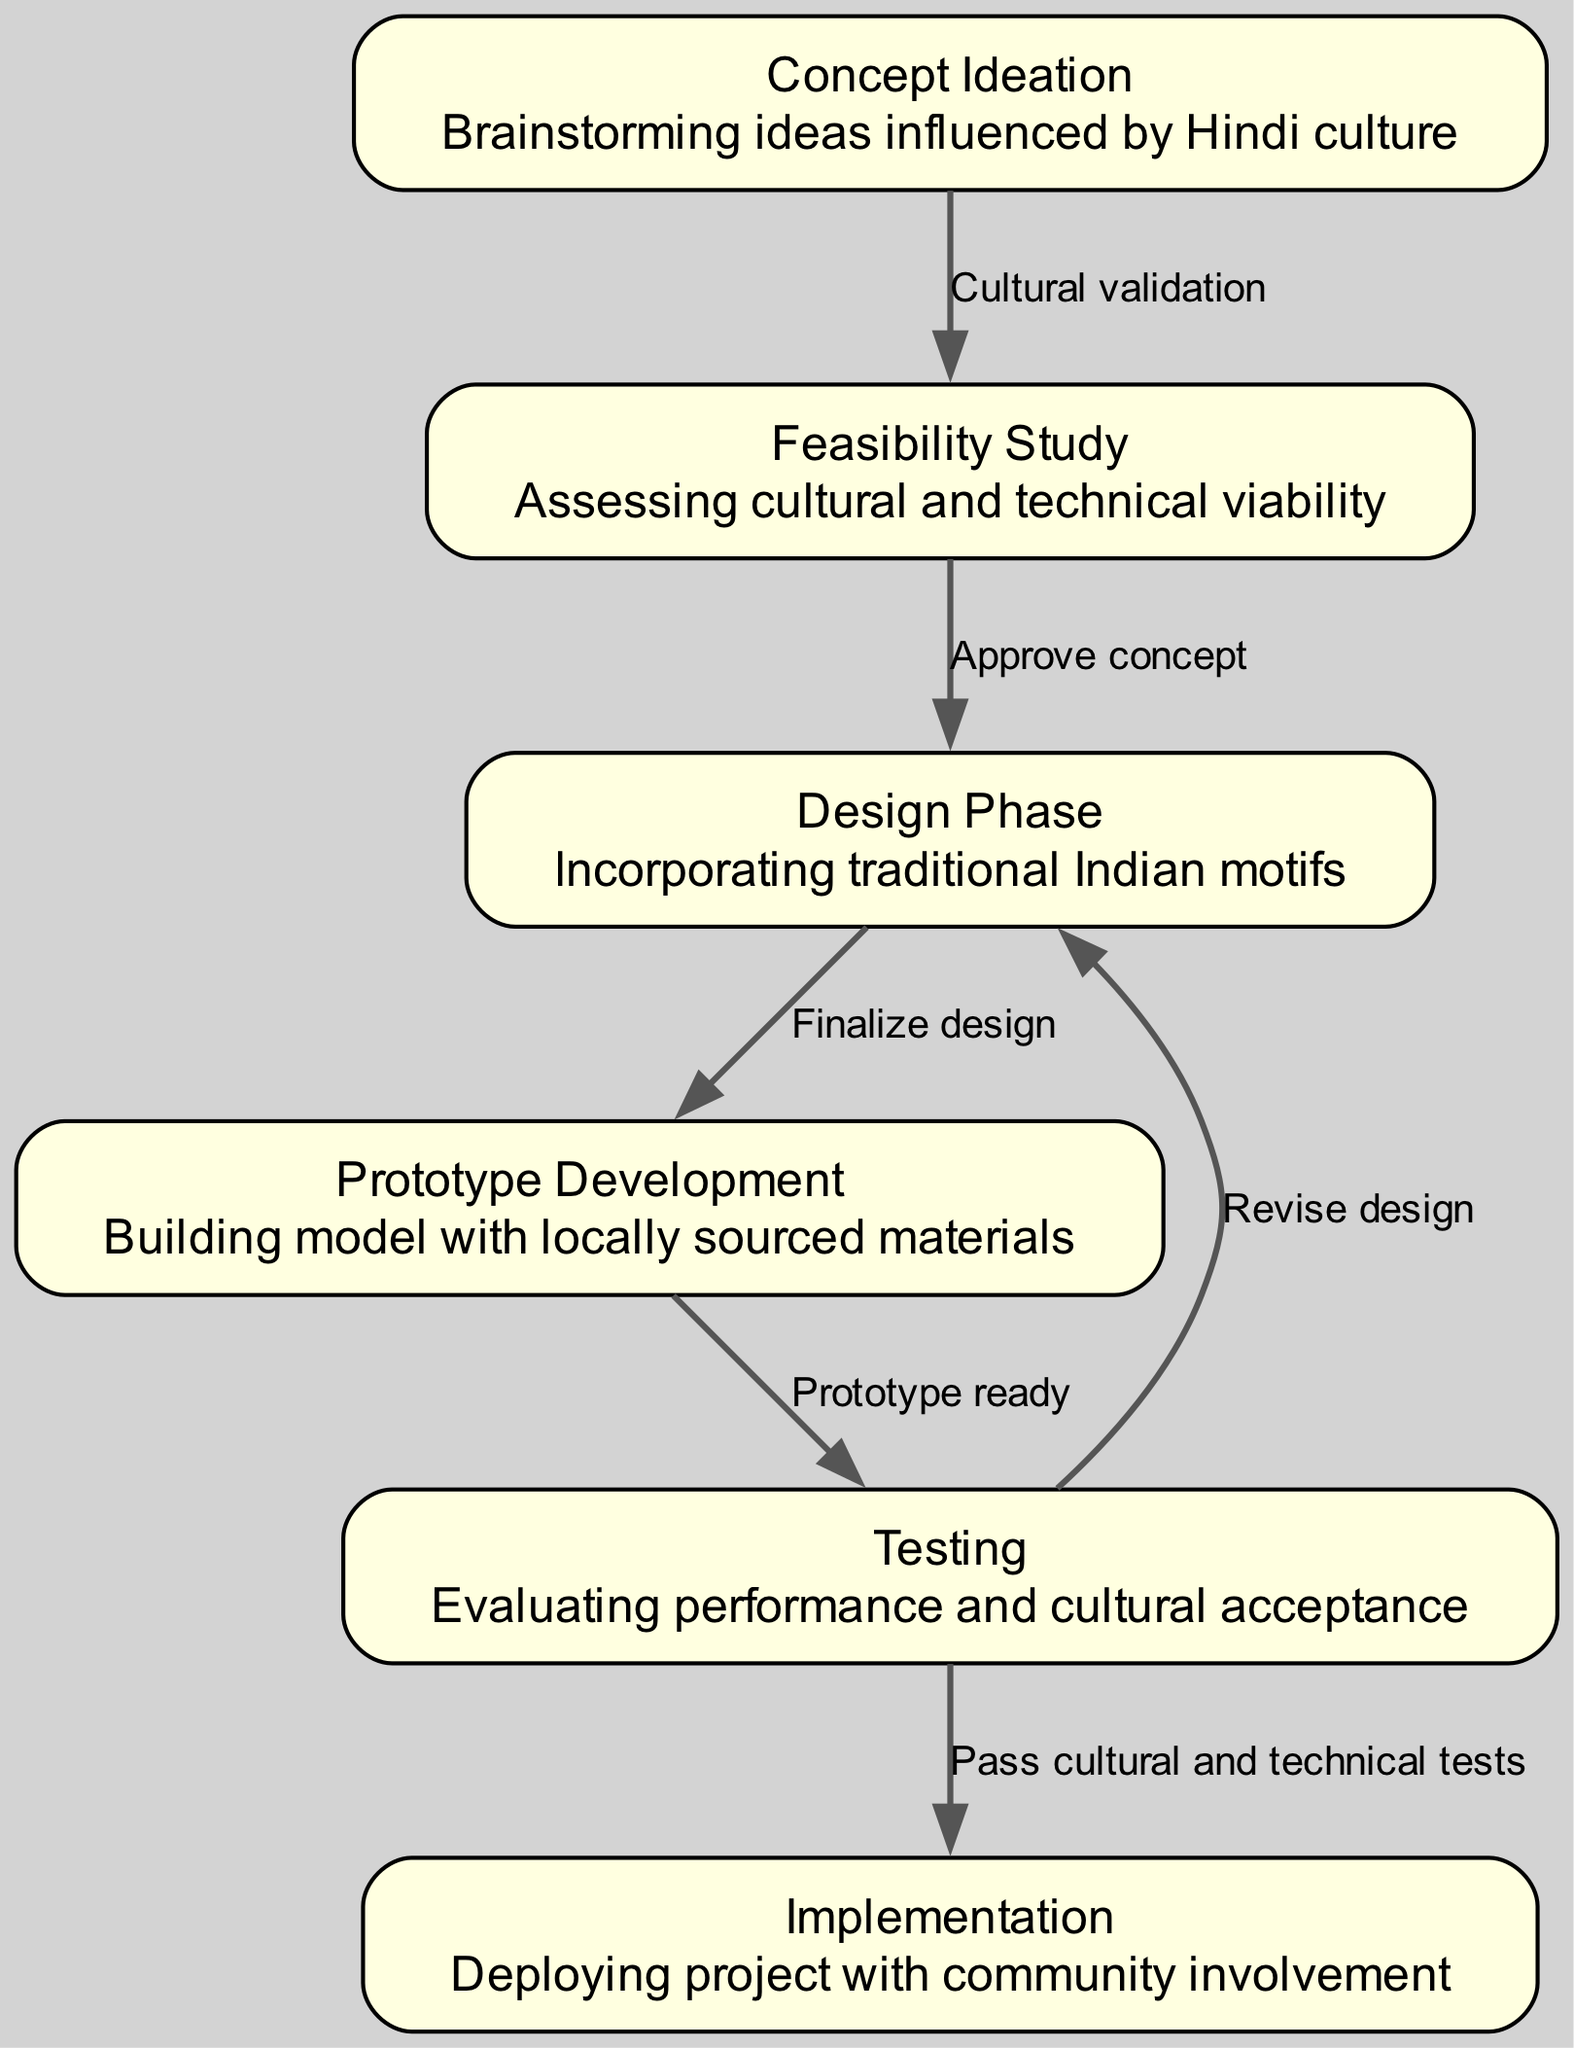What is the first phase in the engineering project lifecycle? The diagram indicates that the first phase is "Concept Ideation". This is found at the top of the state diagram, representing the start of the engineering project lifecycle.
Answer: Concept Ideation How many nodes are there in the diagram? The diagram lists a total of six nodes representing different phases of the engineering project. By counting the nodes, we find that there are six in total.
Answer: Six Which phase comes after the "Feasibility Study"? From the diagram, the phase directly following "Feasibility Study" is "Design Phase". The edges show the progression from one phase to the next, leading from the second node to the third node.
Answer: Design Phase What cultural element is mentioned in the "Design Phase"? The "Design Phase" node notes the incorporation of "traditional Indian motifs". This is part of the description under this node, highlighting the cultural consideration in the design approach.
Answer: traditional Indian motifs How many edges are there in the diagram? By examining the edges that connect the nodes, we see that there are five edges in total. Each edge represents a relationship or transition from one phase to another in the lifecycle of the project.
Answer: Five What happens if the "Testing" phase fails? The diagram indicates that if the "Testing" phase does not pass cultural and technical tests, there is a pathway to "Revise design", which suggests that the project will revert to the "Design Phase" for necessary adjustments before proceeding further.
Answer: Revise design Which phases involve cultural aspects? The "Concept Ideation", "Feasibility Study", "Design Phase", and "Testing" all mention cultural aspects in their descriptions. Each of these phases emphasizes the importance of cultural considerations, underlying the significance throughout the engineering process.
Answer: Concept Ideation, Feasibility Study, Design Phase, Testing What is the label of the edge connecting "Testing" to "Implementation"? The edge that moves from "Testing" to "Implementation" is labeled as "Pass cultural and technical tests". This label describes the condition necessary for the project to move forward into the implementation stage.
Answer: Pass cultural and technical tests 